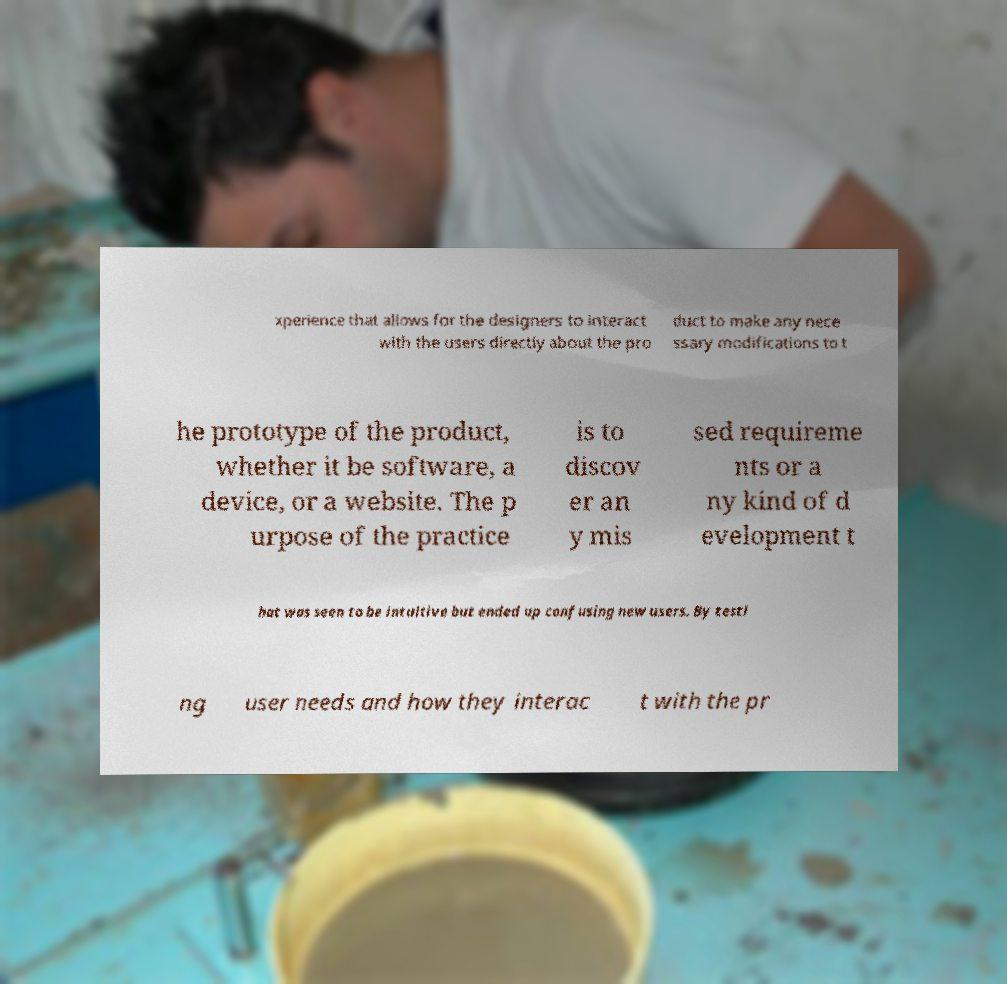I need the written content from this picture converted into text. Can you do that? xperience that allows for the designers to interact with the users directly about the pro duct to make any nece ssary modifications to t he prototype of the product, whether it be software, a device, or a website. The p urpose of the practice is to discov er an y mis sed requireme nts or a ny kind of d evelopment t hat was seen to be intuitive but ended up confusing new users. By testi ng user needs and how they interac t with the pr 